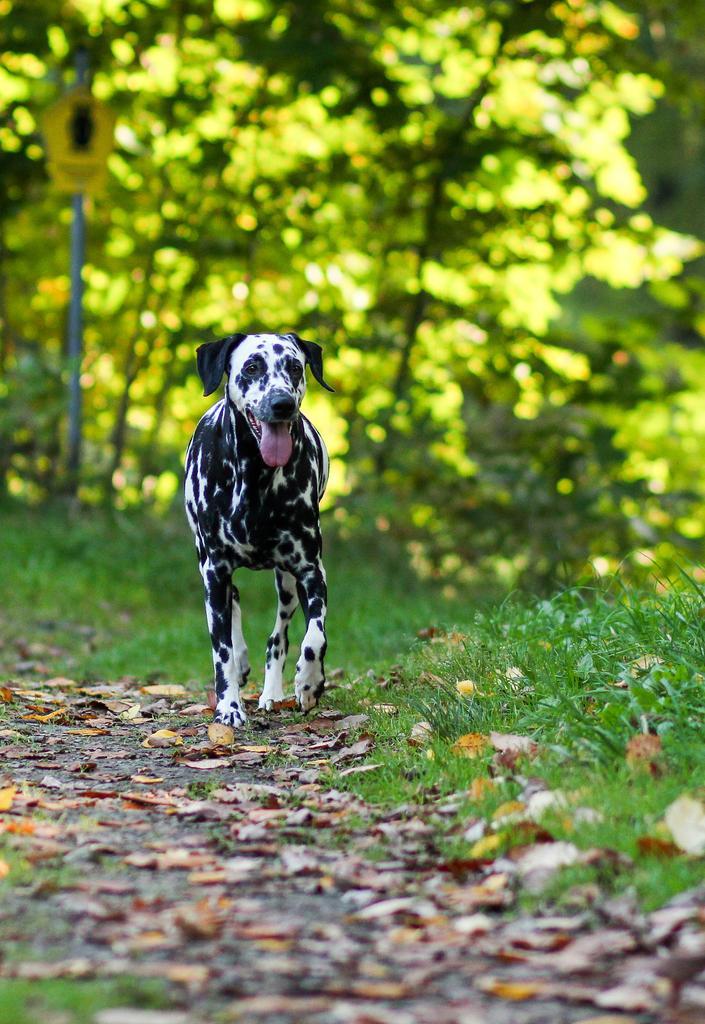Could you give a brief overview of what you see in this image? This image is taken outdoors. At the bottom of the image ground with grass and a few dry leaves on it. In the background there are many trees. In the middle of the image a dog is walking on the ground. 